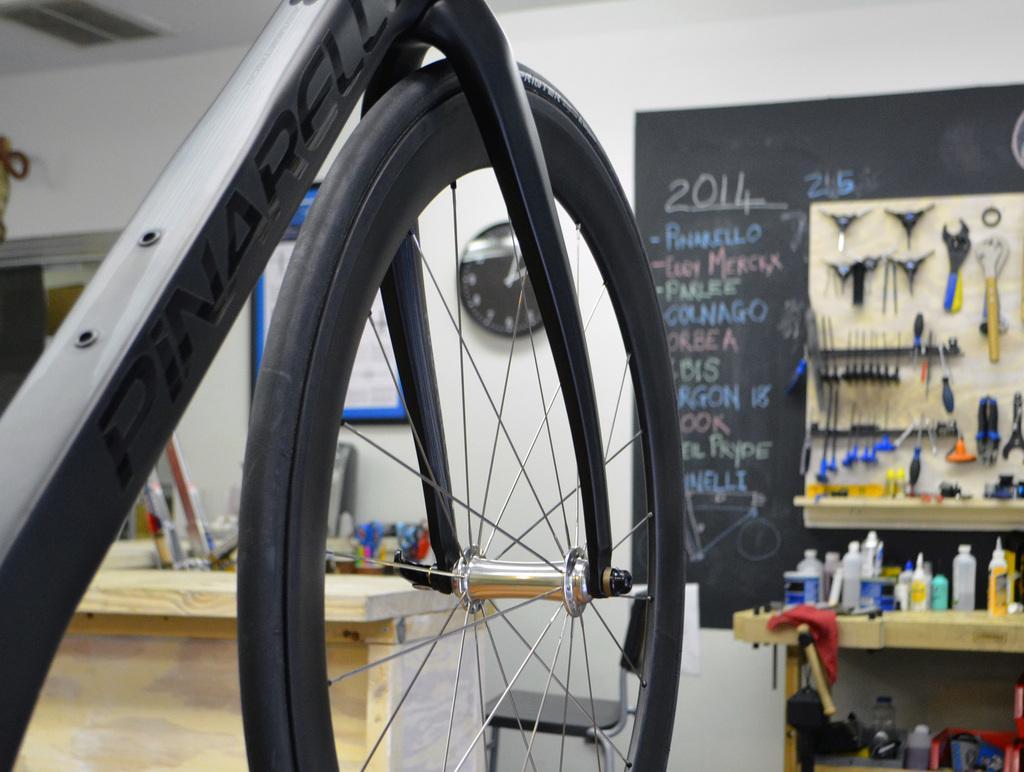Can you describe this image briefly? In this image we can see the bicycle wheel. We can also see the chair, table and also some bottles and some other objects. We can also see the pliers and some objects. There is a black color board with text. We can also see the frame, clock attached to the plain white color wall. Ceiling is also visible in this image. 